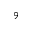<formula> <loc_0><loc_0><loc_500><loc_500>^ { 9 }</formula> 